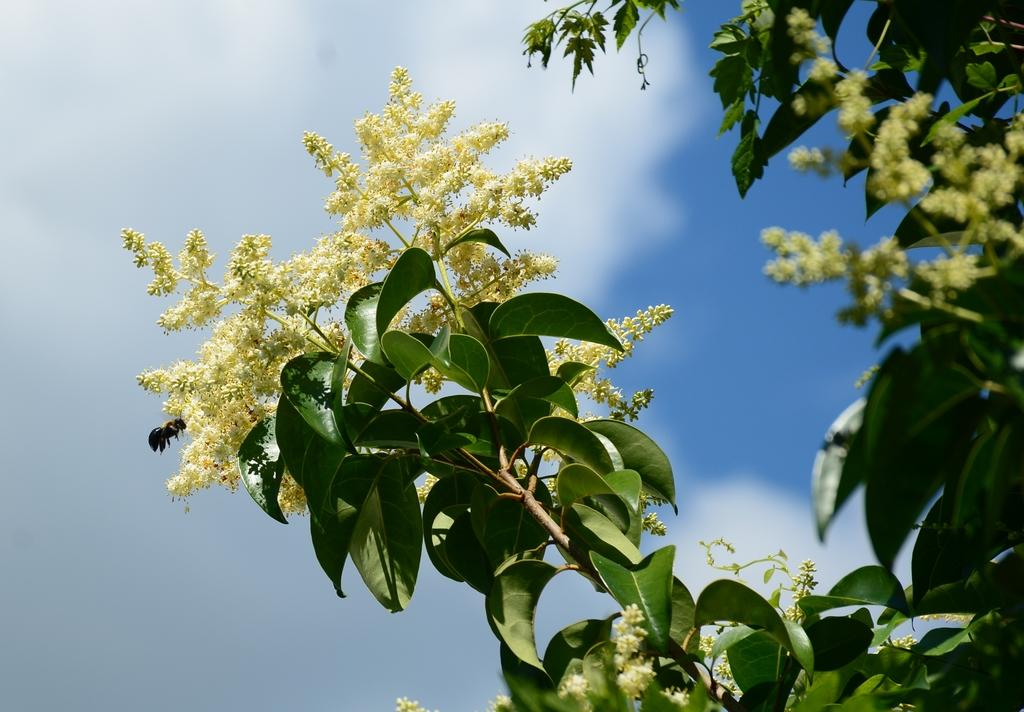What type of tree is in the picture? There is a mango tree in the picture. What else can be seen in the picture besides the tree? There are flowers visible in the picture. What is visible in the background of the picture? The sky is visible in the background of the picture. What can be observed in the sky? Clouds are present in the sky. What is the interest rate on the mango tree in the image? There is no interest rate associated with the mango tree in the image, as it is a living organism and not a financial instrument. 